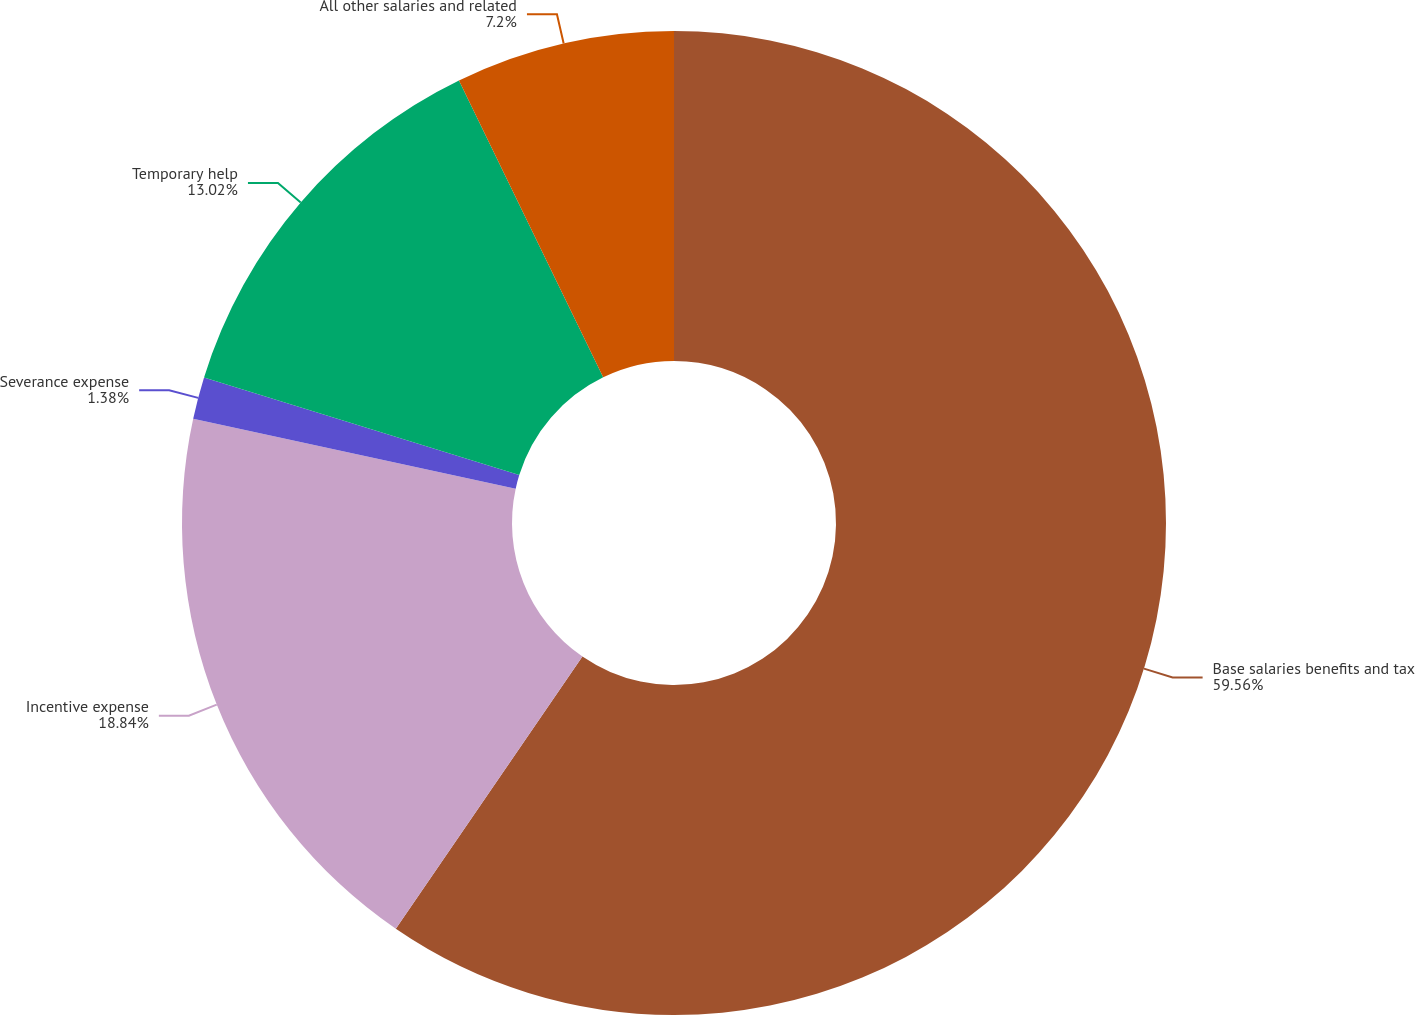Convert chart to OTSL. <chart><loc_0><loc_0><loc_500><loc_500><pie_chart><fcel>Base salaries benefits and tax<fcel>Incentive expense<fcel>Severance expense<fcel>Temporary help<fcel>All other salaries and related<nl><fcel>59.57%<fcel>18.84%<fcel>1.38%<fcel>13.02%<fcel>7.2%<nl></chart> 